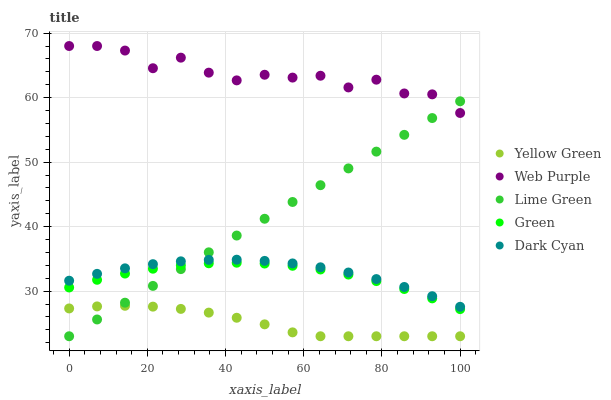Does Yellow Green have the minimum area under the curve?
Answer yes or no. Yes. Does Web Purple have the maximum area under the curve?
Answer yes or no. Yes. Does Green have the minimum area under the curve?
Answer yes or no. No. Does Green have the maximum area under the curve?
Answer yes or no. No. Is Lime Green the smoothest?
Answer yes or no. Yes. Is Web Purple the roughest?
Answer yes or no. Yes. Is Green the smoothest?
Answer yes or no. No. Is Green the roughest?
Answer yes or no. No. Does Lime Green have the lowest value?
Answer yes or no. Yes. Does Green have the lowest value?
Answer yes or no. No. Does Web Purple have the highest value?
Answer yes or no. Yes. Does Green have the highest value?
Answer yes or no. No. Is Yellow Green less than Green?
Answer yes or no. Yes. Is Dark Cyan greater than Yellow Green?
Answer yes or no. Yes. Does Lime Green intersect Web Purple?
Answer yes or no. Yes. Is Lime Green less than Web Purple?
Answer yes or no. No. Is Lime Green greater than Web Purple?
Answer yes or no. No. Does Yellow Green intersect Green?
Answer yes or no. No. 